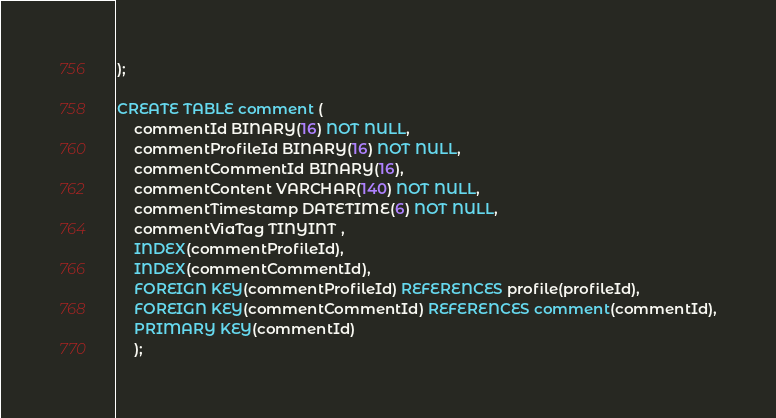<code> <loc_0><loc_0><loc_500><loc_500><_SQL_>);

CREATE TABLE comment (
	commentId BINARY(16) NOT NULL,
	commentProfileId BINARY(16) NOT NULL,
	commentCommentId BINARY(16),
	commentContent VARCHAR(140) NOT NULL,
	commentTimestamp DATETIME(6) NOT NULL,
	commentViaTag TINYINT ,
	INDEX(commentProfileId),
	INDEX(commentCommentId),
	FOREIGN KEY(commentProfileId) REFERENCES profile(profileId),
	FOREIGN KEY(commentCommentId) REFERENCES comment(commentId),
	PRIMARY KEY(commentId)
	);

</code> 